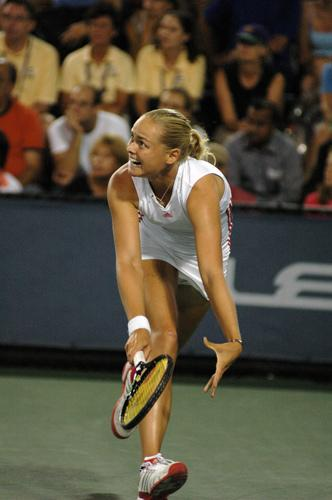What move is this female player making?

Choices:
A) lob
B) serve
C) receive
D) backhand receive 